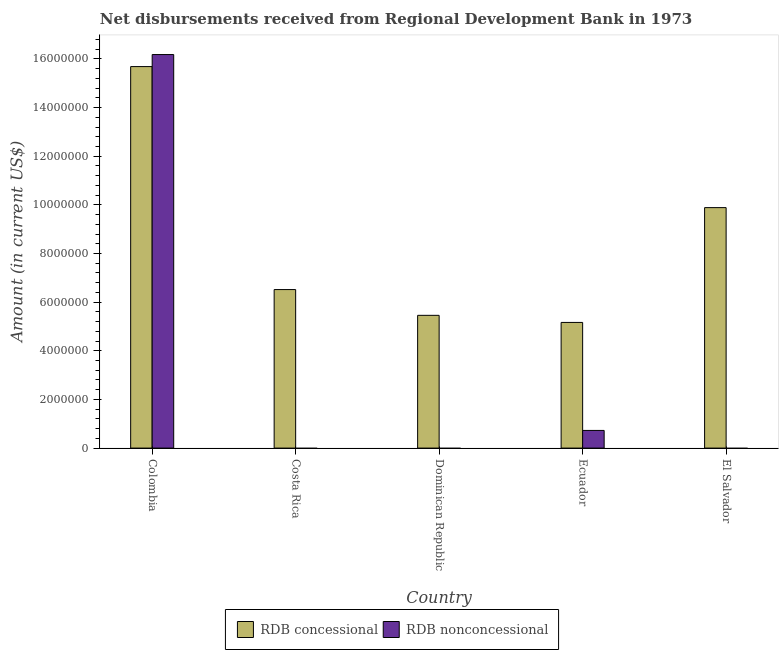How many different coloured bars are there?
Offer a terse response. 2. How many bars are there on the 1st tick from the left?
Provide a short and direct response. 2. How many bars are there on the 4th tick from the right?
Your answer should be very brief. 1. What is the label of the 5th group of bars from the left?
Keep it short and to the point. El Salvador. What is the net non concessional disbursements from rdb in Dominican Republic?
Give a very brief answer. 0. Across all countries, what is the maximum net concessional disbursements from rdb?
Provide a short and direct response. 1.57e+07. What is the total net concessional disbursements from rdb in the graph?
Offer a terse response. 4.27e+07. What is the difference between the net concessional disbursements from rdb in Colombia and that in El Salvador?
Provide a succinct answer. 5.80e+06. What is the difference between the net non concessional disbursements from rdb in Ecuador and the net concessional disbursements from rdb in Dominican Republic?
Provide a short and direct response. -4.73e+06. What is the average net concessional disbursements from rdb per country?
Offer a terse response. 8.54e+06. What is the difference between the net non concessional disbursements from rdb and net concessional disbursements from rdb in Colombia?
Give a very brief answer. 4.95e+05. What is the ratio of the net non concessional disbursements from rdb in Colombia to that in Ecuador?
Give a very brief answer. 22.29. Is the net concessional disbursements from rdb in Costa Rica less than that in Dominican Republic?
Keep it short and to the point. No. What is the difference between the highest and the second highest net concessional disbursements from rdb?
Provide a succinct answer. 5.80e+06. What is the difference between the highest and the lowest net non concessional disbursements from rdb?
Ensure brevity in your answer.  1.62e+07. Is the sum of the net concessional disbursements from rdb in Ecuador and El Salvador greater than the maximum net non concessional disbursements from rdb across all countries?
Offer a very short reply. No. How many bars are there?
Offer a very short reply. 7. What is the difference between two consecutive major ticks on the Y-axis?
Give a very brief answer. 2.00e+06. How many legend labels are there?
Offer a very short reply. 2. How are the legend labels stacked?
Offer a very short reply. Horizontal. What is the title of the graph?
Ensure brevity in your answer.  Net disbursements received from Regional Development Bank in 1973. What is the Amount (in current US$) of RDB concessional in Colombia?
Ensure brevity in your answer.  1.57e+07. What is the Amount (in current US$) in RDB nonconcessional in Colombia?
Give a very brief answer. 1.62e+07. What is the Amount (in current US$) of RDB concessional in Costa Rica?
Make the answer very short. 6.52e+06. What is the Amount (in current US$) in RDB concessional in Dominican Republic?
Your answer should be very brief. 5.46e+06. What is the Amount (in current US$) of RDB nonconcessional in Dominican Republic?
Your response must be concise. 0. What is the Amount (in current US$) in RDB concessional in Ecuador?
Give a very brief answer. 5.17e+06. What is the Amount (in current US$) in RDB nonconcessional in Ecuador?
Offer a terse response. 7.26e+05. What is the Amount (in current US$) in RDB concessional in El Salvador?
Provide a short and direct response. 9.89e+06. What is the Amount (in current US$) of RDB nonconcessional in El Salvador?
Keep it short and to the point. 0. Across all countries, what is the maximum Amount (in current US$) in RDB concessional?
Provide a short and direct response. 1.57e+07. Across all countries, what is the maximum Amount (in current US$) of RDB nonconcessional?
Offer a very short reply. 1.62e+07. Across all countries, what is the minimum Amount (in current US$) of RDB concessional?
Ensure brevity in your answer.  5.17e+06. What is the total Amount (in current US$) in RDB concessional in the graph?
Give a very brief answer. 4.27e+07. What is the total Amount (in current US$) in RDB nonconcessional in the graph?
Your answer should be very brief. 1.69e+07. What is the difference between the Amount (in current US$) in RDB concessional in Colombia and that in Costa Rica?
Ensure brevity in your answer.  9.17e+06. What is the difference between the Amount (in current US$) in RDB concessional in Colombia and that in Dominican Republic?
Provide a short and direct response. 1.02e+07. What is the difference between the Amount (in current US$) of RDB concessional in Colombia and that in Ecuador?
Offer a very short reply. 1.05e+07. What is the difference between the Amount (in current US$) in RDB nonconcessional in Colombia and that in Ecuador?
Offer a very short reply. 1.55e+07. What is the difference between the Amount (in current US$) in RDB concessional in Colombia and that in El Salvador?
Make the answer very short. 5.80e+06. What is the difference between the Amount (in current US$) of RDB concessional in Costa Rica and that in Dominican Republic?
Your answer should be very brief. 1.06e+06. What is the difference between the Amount (in current US$) of RDB concessional in Costa Rica and that in Ecuador?
Ensure brevity in your answer.  1.35e+06. What is the difference between the Amount (in current US$) in RDB concessional in Costa Rica and that in El Salvador?
Your answer should be compact. -3.37e+06. What is the difference between the Amount (in current US$) of RDB concessional in Dominican Republic and that in Ecuador?
Your answer should be compact. 2.92e+05. What is the difference between the Amount (in current US$) in RDB concessional in Dominican Republic and that in El Salvador?
Give a very brief answer. -4.43e+06. What is the difference between the Amount (in current US$) in RDB concessional in Ecuador and that in El Salvador?
Make the answer very short. -4.72e+06. What is the difference between the Amount (in current US$) of RDB concessional in Colombia and the Amount (in current US$) of RDB nonconcessional in Ecuador?
Offer a very short reply. 1.50e+07. What is the difference between the Amount (in current US$) of RDB concessional in Costa Rica and the Amount (in current US$) of RDB nonconcessional in Ecuador?
Offer a terse response. 5.79e+06. What is the difference between the Amount (in current US$) of RDB concessional in Dominican Republic and the Amount (in current US$) of RDB nonconcessional in Ecuador?
Offer a very short reply. 4.73e+06. What is the average Amount (in current US$) in RDB concessional per country?
Your answer should be compact. 8.54e+06. What is the average Amount (in current US$) in RDB nonconcessional per country?
Provide a succinct answer. 3.38e+06. What is the difference between the Amount (in current US$) of RDB concessional and Amount (in current US$) of RDB nonconcessional in Colombia?
Your response must be concise. -4.95e+05. What is the difference between the Amount (in current US$) in RDB concessional and Amount (in current US$) in RDB nonconcessional in Ecuador?
Make the answer very short. 4.44e+06. What is the ratio of the Amount (in current US$) in RDB concessional in Colombia to that in Costa Rica?
Offer a very short reply. 2.41. What is the ratio of the Amount (in current US$) of RDB concessional in Colombia to that in Dominican Republic?
Your response must be concise. 2.87. What is the ratio of the Amount (in current US$) in RDB concessional in Colombia to that in Ecuador?
Your answer should be compact. 3.04. What is the ratio of the Amount (in current US$) of RDB nonconcessional in Colombia to that in Ecuador?
Offer a very short reply. 22.29. What is the ratio of the Amount (in current US$) of RDB concessional in Colombia to that in El Salvador?
Keep it short and to the point. 1.59. What is the ratio of the Amount (in current US$) in RDB concessional in Costa Rica to that in Dominican Republic?
Your response must be concise. 1.19. What is the ratio of the Amount (in current US$) of RDB concessional in Costa Rica to that in Ecuador?
Your answer should be compact. 1.26. What is the ratio of the Amount (in current US$) in RDB concessional in Costa Rica to that in El Salvador?
Offer a terse response. 0.66. What is the ratio of the Amount (in current US$) of RDB concessional in Dominican Republic to that in Ecuador?
Ensure brevity in your answer.  1.06. What is the ratio of the Amount (in current US$) in RDB concessional in Dominican Republic to that in El Salvador?
Keep it short and to the point. 0.55. What is the ratio of the Amount (in current US$) in RDB concessional in Ecuador to that in El Salvador?
Your answer should be compact. 0.52. What is the difference between the highest and the second highest Amount (in current US$) of RDB concessional?
Provide a short and direct response. 5.80e+06. What is the difference between the highest and the lowest Amount (in current US$) of RDB concessional?
Provide a short and direct response. 1.05e+07. What is the difference between the highest and the lowest Amount (in current US$) in RDB nonconcessional?
Provide a short and direct response. 1.62e+07. 